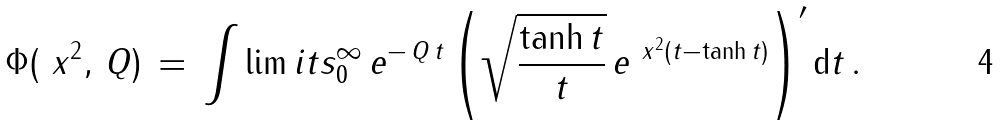<formula> <loc_0><loc_0><loc_500><loc_500>\Phi ( { \ x } ^ { 2 } , \, Q ) \, = \, \int \lim i t s ^ { \infty } _ { 0 } \, e ^ { - \, Q \, t } \left ( \sqrt { \frac { \tanh t } t } \, e ^ { { \ x } ^ { 2 } ( t - \tanh t ) } \right ) ^ { \prime } { \text  d}t\,.</formula> 